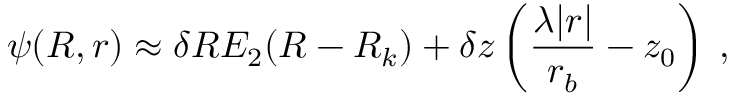Convert formula to latex. <formula><loc_0><loc_0><loc_500><loc_500>\psi ( R , r ) \approx \delta R E _ { 2 } ( R - R _ { k } ) + \delta z \left ( \frac { \lambda | r | } { r _ { b } } - z _ { 0 } \right ) \, ,</formula> 